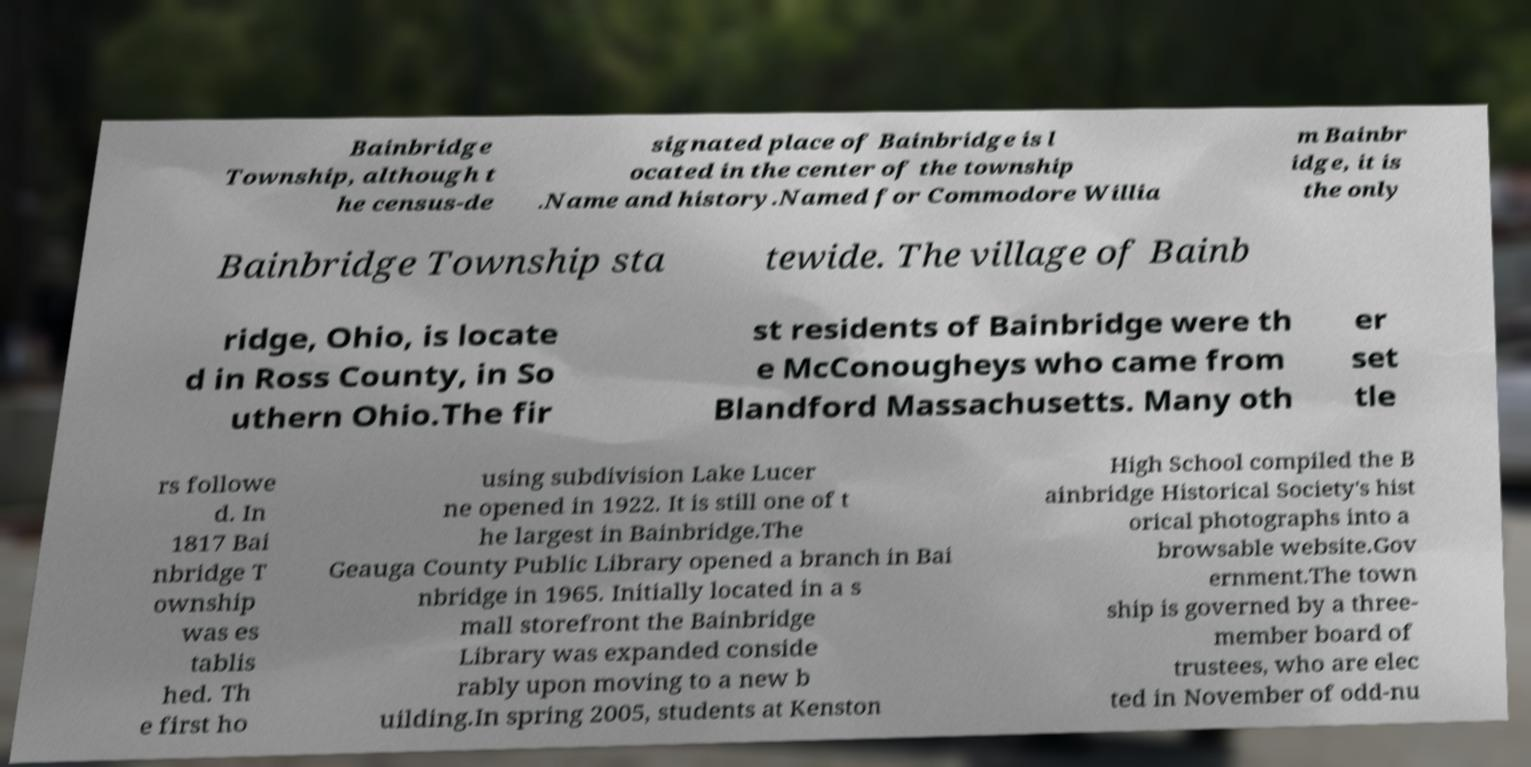Could you extract and type out the text from this image? Bainbridge Township, although t he census-de signated place of Bainbridge is l ocated in the center of the township .Name and history.Named for Commodore Willia m Bainbr idge, it is the only Bainbridge Township sta tewide. The village of Bainb ridge, Ohio, is locate d in Ross County, in So uthern Ohio.The fir st residents of Bainbridge were th e McConougheys who came from Blandford Massachusetts. Many oth er set tle rs followe d. In 1817 Bai nbridge T ownship was es tablis hed. Th e first ho using subdivision Lake Lucer ne opened in 1922. It is still one of t he largest in Bainbridge.The Geauga County Public Library opened a branch in Bai nbridge in 1965. Initially located in a s mall storefront the Bainbridge Library was expanded conside rably upon moving to a new b uilding.In spring 2005, students at Kenston High School compiled the B ainbridge Historical Society's hist orical photographs into a browsable website.Gov ernment.The town ship is governed by a three- member board of trustees, who are elec ted in November of odd-nu 